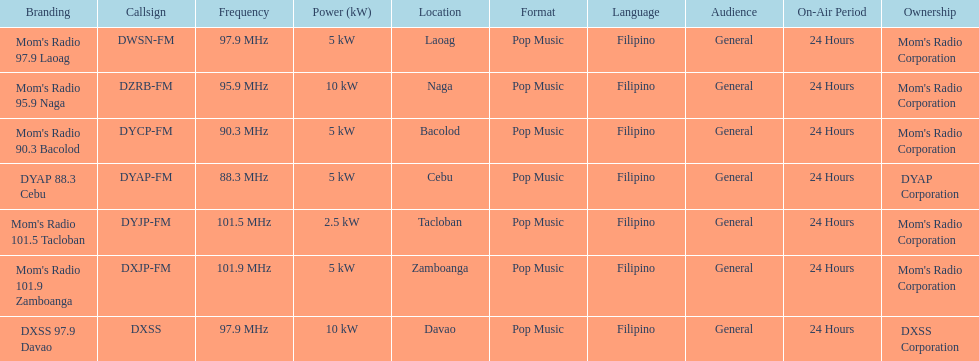What is the radio with the most mhz? Mom's Radio 101.9 Zamboanga. 